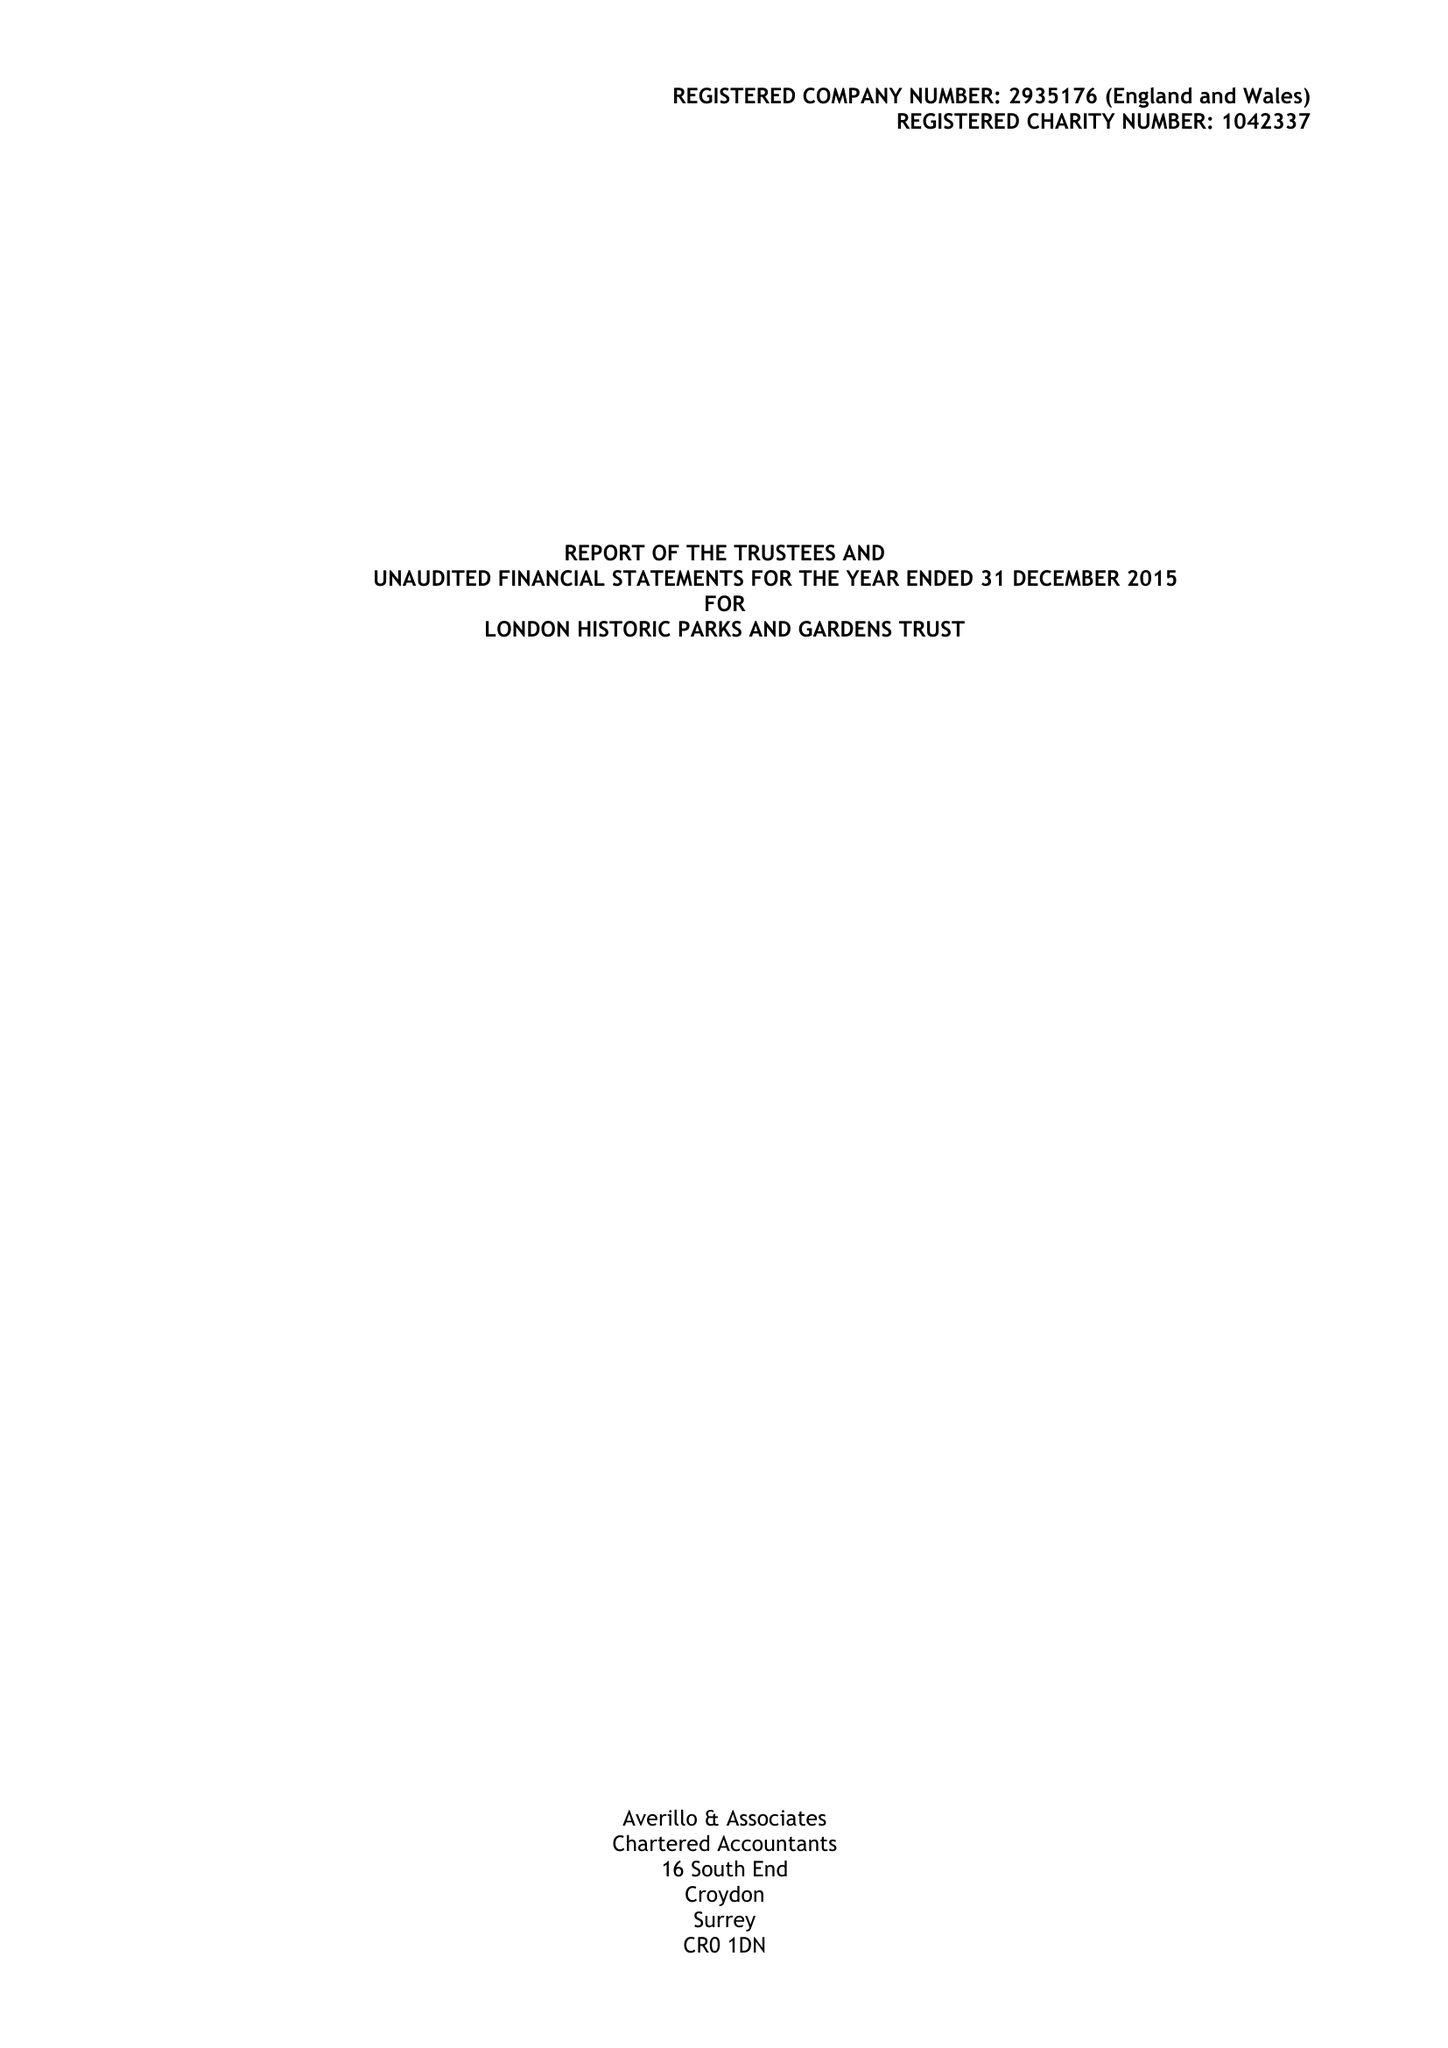What is the value for the spending_annually_in_british_pounds?
Answer the question using a single word or phrase. 153855.00 